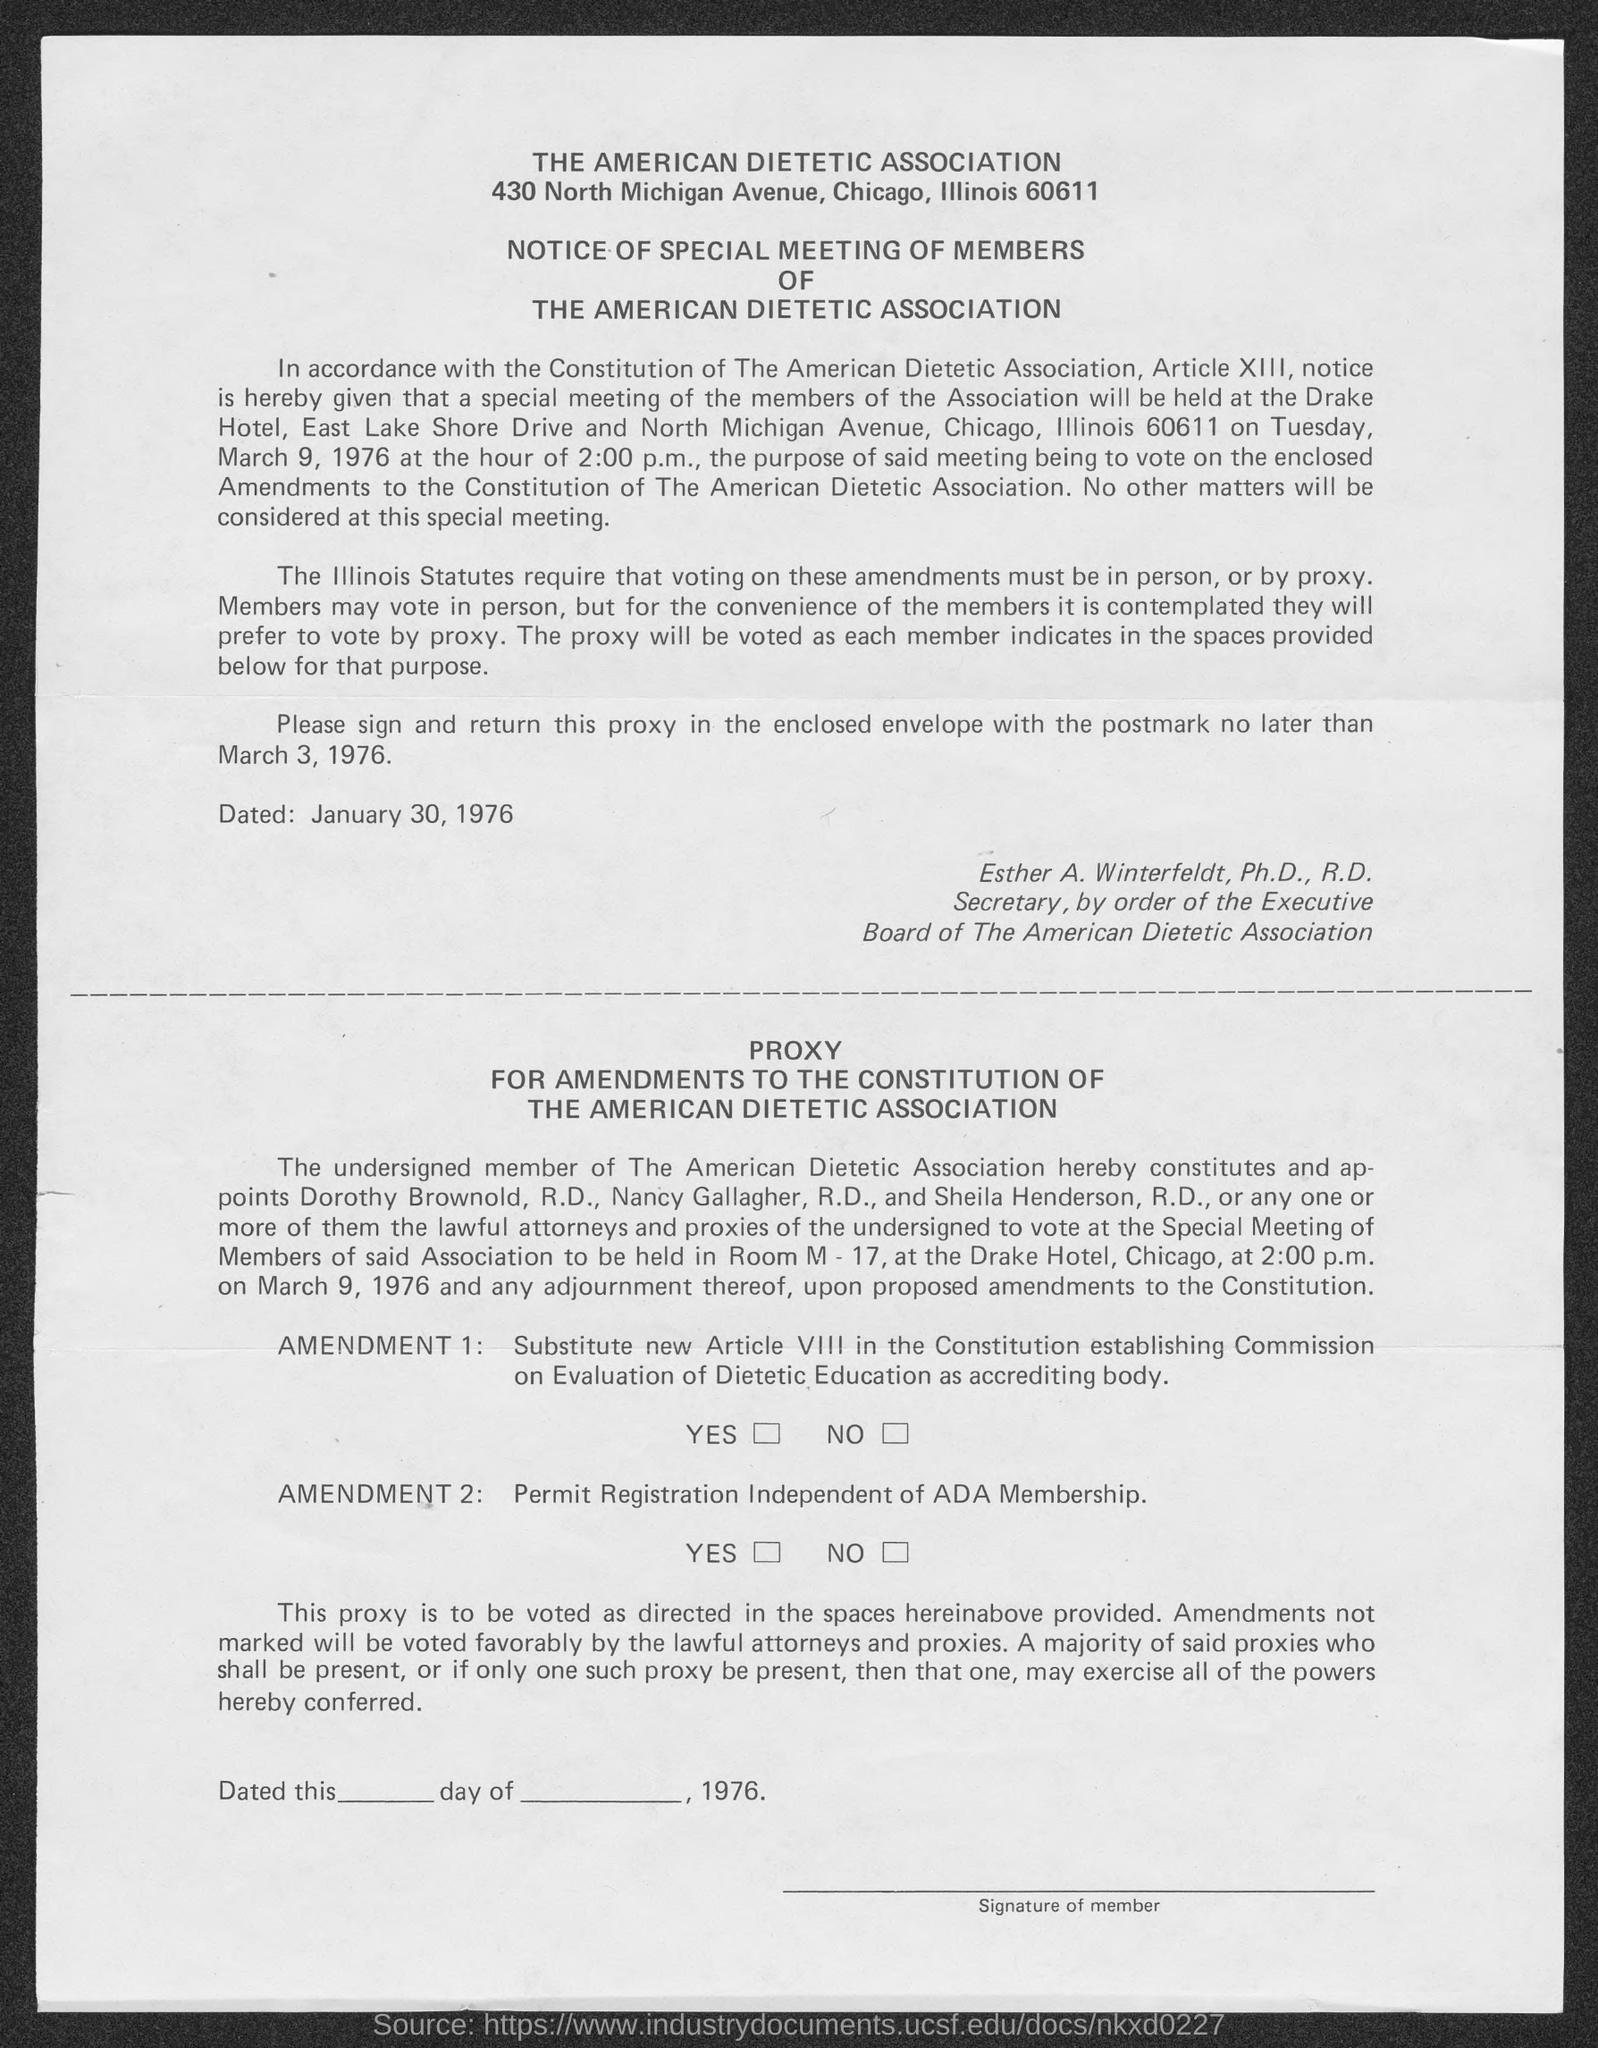What is the first title in the document?
Offer a terse response. The American Dietetic Association. Who is the secretary of the board of the American dietetic association?
Give a very brief answer. Esther A. Winterfeldt. 